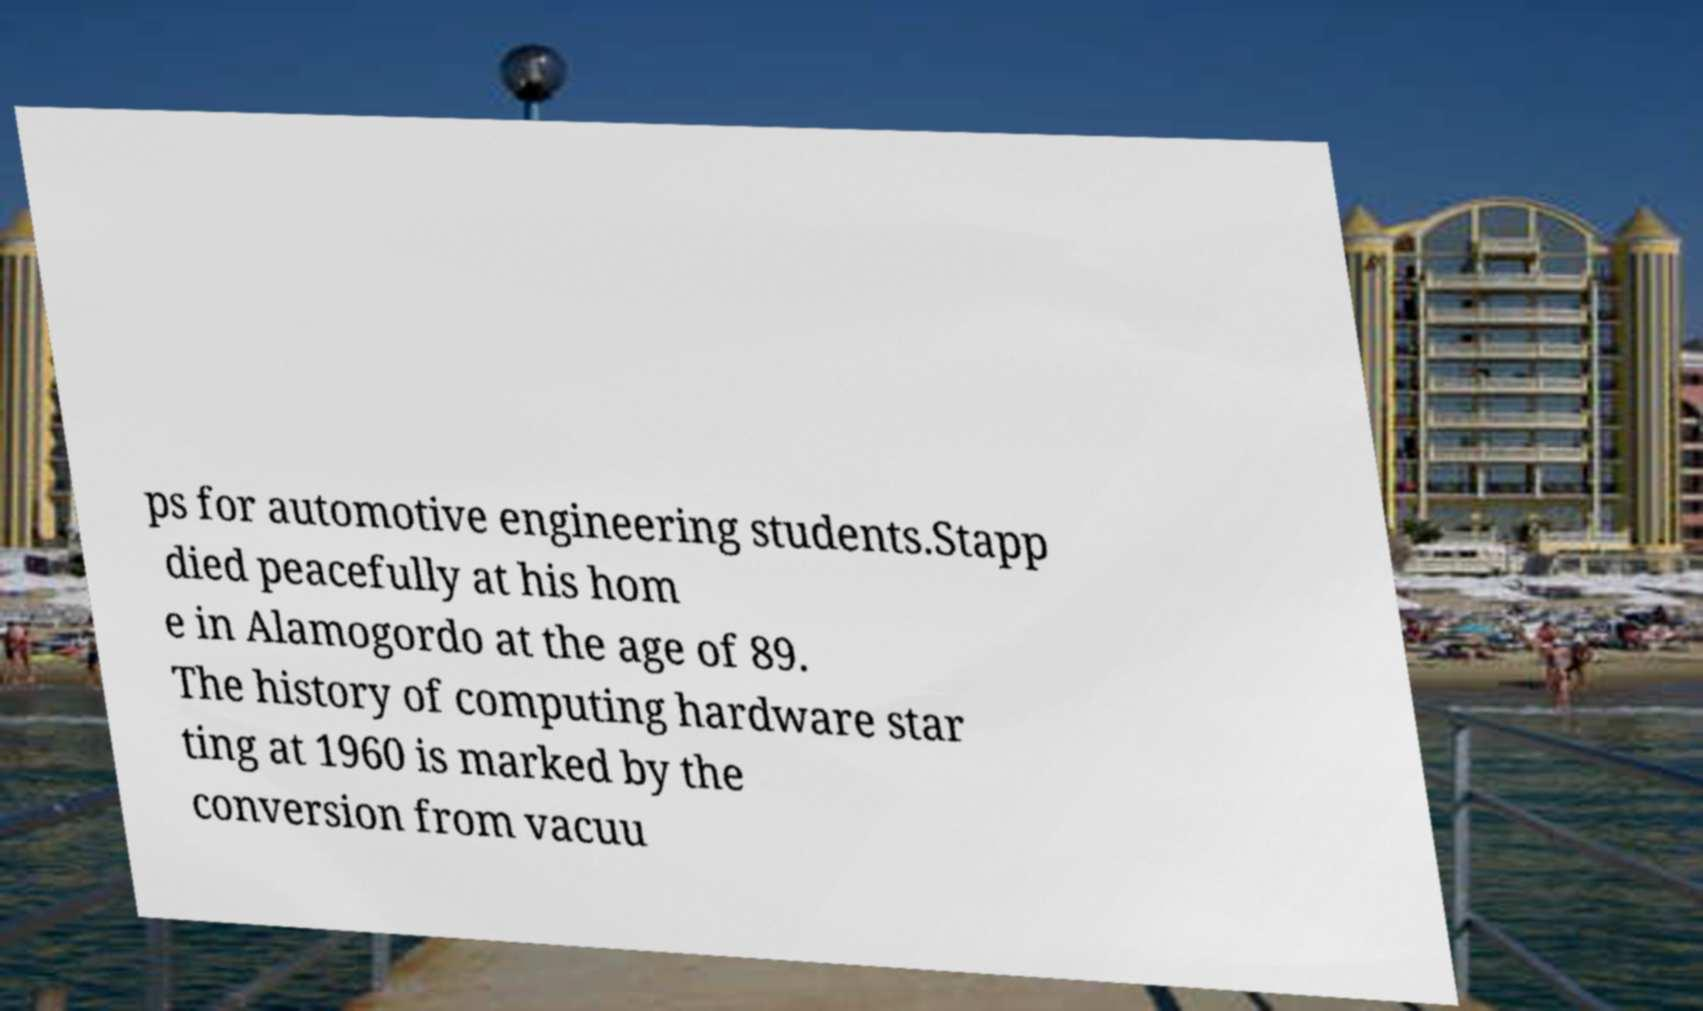What messages or text are displayed in this image? I need them in a readable, typed format. ps for automotive engineering students.Stapp died peacefully at his hom e in Alamogordo at the age of 89. The history of computing hardware star ting at 1960 is marked by the conversion from vacuu 